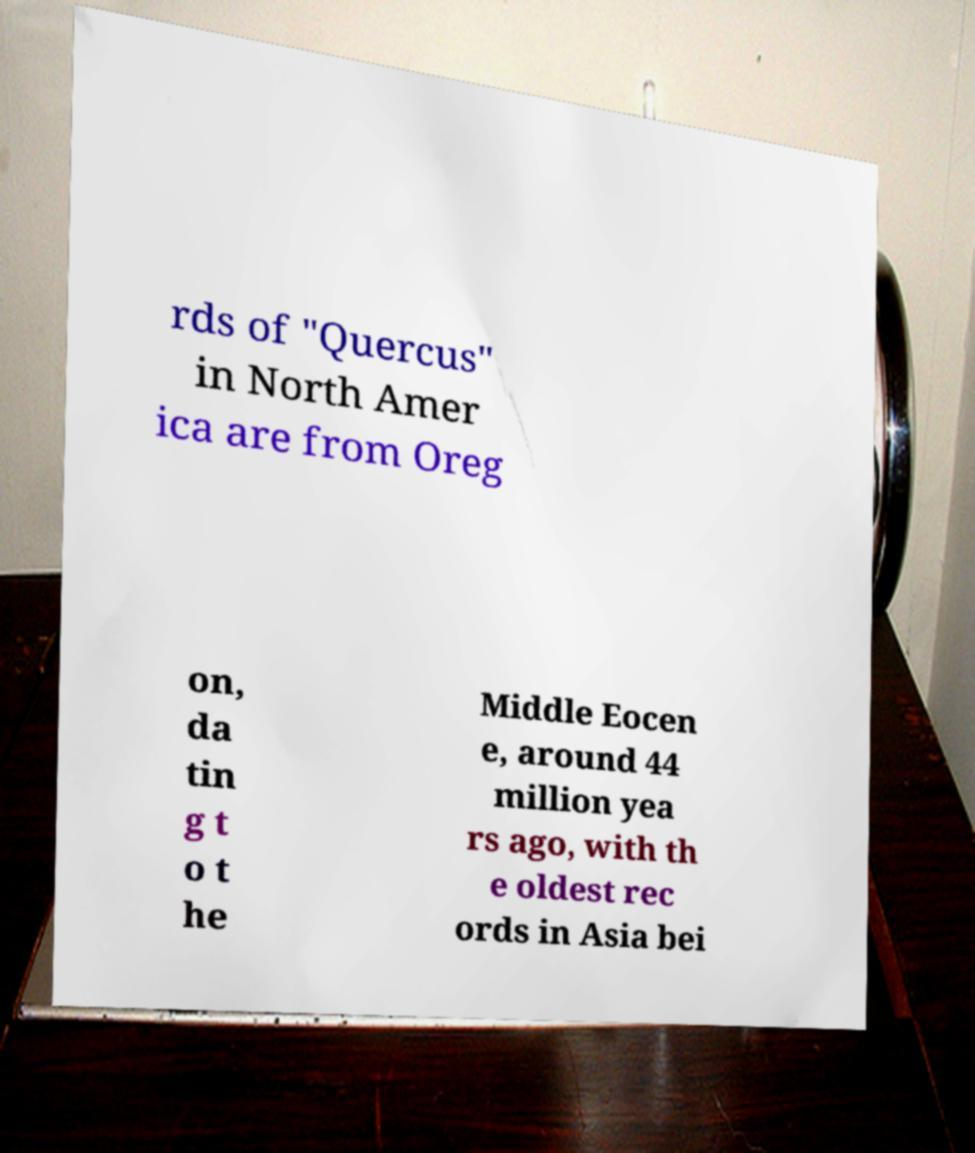Can you read and provide the text displayed in the image?This photo seems to have some interesting text. Can you extract and type it out for me? rds of "Quercus" in North Amer ica are from Oreg on, da tin g t o t he Middle Eocen e, around 44 million yea rs ago, with th e oldest rec ords in Asia bei 